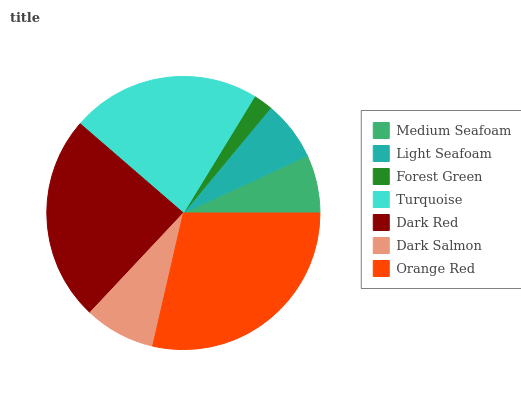Is Forest Green the minimum?
Answer yes or no. Yes. Is Orange Red the maximum?
Answer yes or no. Yes. Is Light Seafoam the minimum?
Answer yes or no. No. Is Light Seafoam the maximum?
Answer yes or no. No. Is Light Seafoam greater than Medium Seafoam?
Answer yes or no. Yes. Is Medium Seafoam less than Light Seafoam?
Answer yes or no. Yes. Is Medium Seafoam greater than Light Seafoam?
Answer yes or no. No. Is Light Seafoam less than Medium Seafoam?
Answer yes or no. No. Is Dark Salmon the high median?
Answer yes or no. Yes. Is Dark Salmon the low median?
Answer yes or no. Yes. Is Dark Red the high median?
Answer yes or no. No. Is Turquoise the low median?
Answer yes or no. No. 